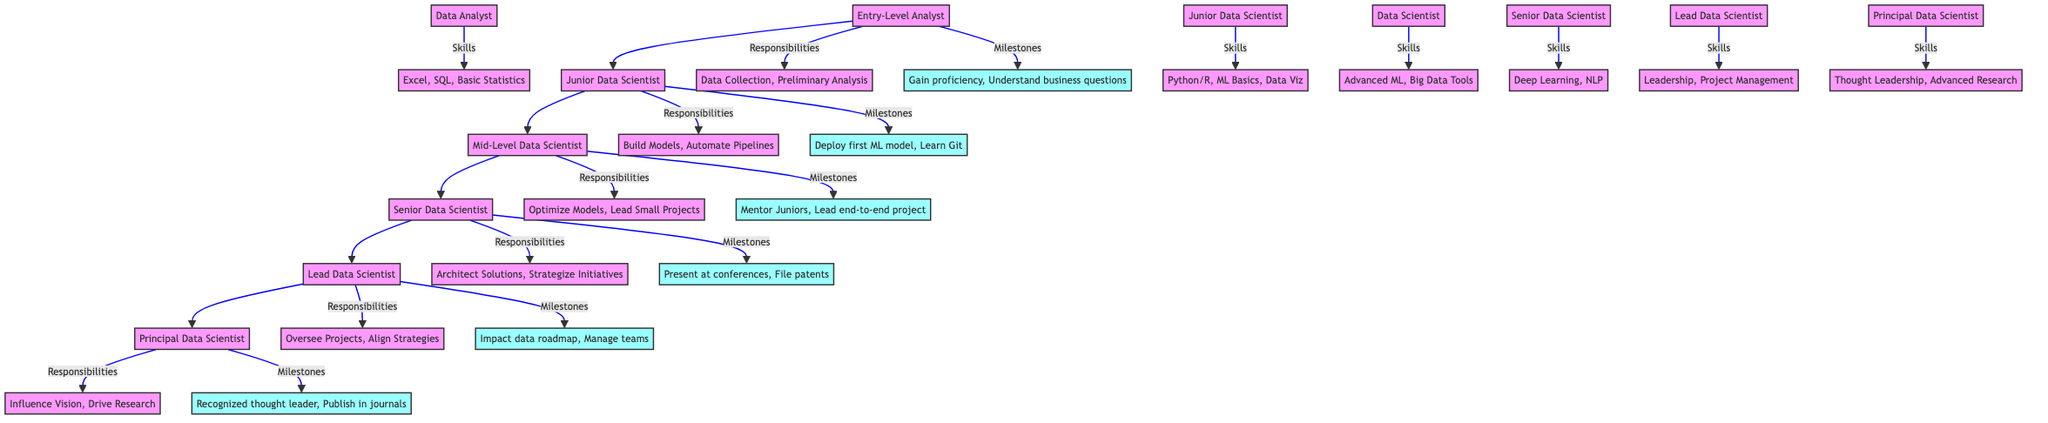What is the title at the highest level in the diagram? The highest level in the diagram is represented by the node labeled "Principal Data Scientist," which denotes the top position in the career progression flow.
Answer: Principal Data Scientist How many total career levels are listed in the diagram? Counting from the bottom level up to the top, there are six distinct career levels represented in the diagram: Entry-Level Analyst, Junior Data Scientist, Mid-Level Data Scientist, Senior Data Scientist, Lead Data Scientist, and Principal Data Scientist.
Answer: Six What responsibilities are associated with a Senior Data Scientist? The responsibilities for a Senior Data Scientist are listed as: Architect Complex Solutions, Strategize Data Science Initiatives, and Collaborate with Cross-functional Teams, found in the respective node.
Answer: Architect Complex Solutions, Strategize Data Science Initiatives, Collaborate with Cross-functional Teams Which skills are required for the Junior Data Scientist level? The skills listed under Junior Data Scientist include Python/R, Machine Learning Basics, Data Visualization, and A/B Testing, located in the node connected to the Junior Data Scientist level.
Answer: Python/R, Machine Learning Basics, Data Visualization, A/B Testing What milestone is achieved right before becoming a Lead Data Scientist? The milestone achieved before moving to the Lead Data Scientist level is "Impact the company's data roadmap," highlighting a significant accomplishment from the prior position.
Answer: Impact the company's data roadmap Which levels are directly connected to Mid-Level Data Scientist? The Mid-Level Data Scientist level receives connections from the levels below and above it: Junior Data Scientist (below) and Senior Data Scientist (above). Thus, it is connected to both these levels.
Answer: Junior Data Scientist, Senior Data Scientist What is the main responsibility of a Principal Data Scientist? The principal responsibility of a Principal Data Scientist is indicated as "Influence Company's Data Vision," summarized as their key focus area in the diagram, which exemplifies the strategic nature of the role.
Answer: Influence Company's Data Vision Which skills are common to a Lead Data Scientist? The skills required for a Lead Data Scientist are Leadership Skills, Project Management, and Business Strategy Alignment, which showcase the leadership and management aspects necessary for the role.
Answer: Leadership Skills, Project Management, Business Strategy Alignment 